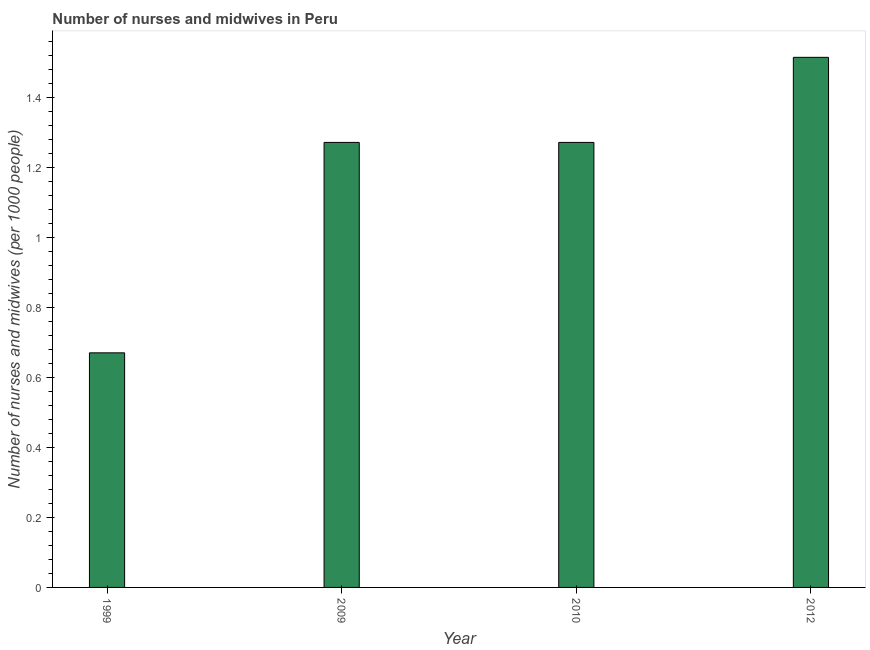Does the graph contain any zero values?
Your answer should be compact. No. What is the title of the graph?
Offer a terse response. Number of nurses and midwives in Peru. What is the label or title of the Y-axis?
Your response must be concise. Number of nurses and midwives (per 1000 people). What is the number of nurses and midwives in 2009?
Offer a terse response. 1.27. Across all years, what is the maximum number of nurses and midwives?
Your answer should be compact. 1.51. Across all years, what is the minimum number of nurses and midwives?
Your response must be concise. 0.67. In which year was the number of nurses and midwives maximum?
Offer a terse response. 2012. What is the sum of the number of nurses and midwives?
Your answer should be very brief. 4.73. What is the difference between the number of nurses and midwives in 1999 and 2009?
Your response must be concise. -0.6. What is the average number of nurses and midwives per year?
Your answer should be compact. 1.18. What is the median number of nurses and midwives?
Provide a succinct answer. 1.27. In how many years, is the number of nurses and midwives greater than 1.52 ?
Provide a short and direct response. 0. Do a majority of the years between 1999 and 2012 (inclusive) have number of nurses and midwives greater than 0.04 ?
Your response must be concise. Yes. What is the ratio of the number of nurses and midwives in 1999 to that in 2009?
Keep it short and to the point. 0.53. Is the difference between the number of nurses and midwives in 2010 and 2012 greater than the difference between any two years?
Offer a terse response. No. What is the difference between the highest and the second highest number of nurses and midwives?
Make the answer very short. 0.24. Is the sum of the number of nurses and midwives in 1999 and 2010 greater than the maximum number of nurses and midwives across all years?
Your answer should be compact. Yes. What is the difference between the highest and the lowest number of nurses and midwives?
Your answer should be very brief. 0.84. In how many years, is the number of nurses and midwives greater than the average number of nurses and midwives taken over all years?
Your answer should be very brief. 3. How many bars are there?
Provide a short and direct response. 4. How many years are there in the graph?
Your response must be concise. 4. Are the values on the major ticks of Y-axis written in scientific E-notation?
Keep it short and to the point. No. What is the Number of nurses and midwives (per 1000 people) of 1999?
Ensure brevity in your answer.  0.67. What is the Number of nurses and midwives (per 1000 people) of 2009?
Offer a terse response. 1.27. What is the Number of nurses and midwives (per 1000 people) in 2010?
Provide a succinct answer. 1.27. What is the Number of nurses and midwives (per 1000 people) of 2012?
Make the answer very short. 1.51. What is the difference between the Number of nurses and midwives (per 1000 people) in 1999 and 2009?
Your answer should be very brief. -0.6. What is the difference between the Number of nurses and midwives (per 1000 people) in 1999 and 2010?
Your answer should be compact. -0.6. What is the difference between the Number of nurses and midwives (per 1000 people) in 1999 and 2012?
Make the answer very short. -0.84. What is the difference between the Number of nurses and midwives (per 1000 people) in 2009 and 2012?
Your answer should be very brief. -0.24. What is the difference between the Number of nurses and midwives (per 1000 people) in 2010 and 2012?
Ensure brevity in your answer.  -0.24. What is the ratio of the Number of nurses and midwives (per 1000 people) in 1999 to that in 2009?
Provide a succinct answer. 0.53. What is the ratio of the Number of nurses and midwives (per 1000 people) in 1999 to that in 2010?
Your response must be concise. 0.53. What is the ratio of the Number of nurses and midwives (per 1000 people) in 1999 to that in 2012?
Offer a very short reply. 0.44. What is the ratio of the Number of nurses and midwives (per 1000 people) in 2009 to that in 2010?
Offer a terse response. 1. What is the ratio of the Number of nurses and midwives (per 1000 people) in 2009 to that in 2012?
Provide a succinct answer. 0.84. What is the ratio of the Number of nurses and midwives (per 1000 people) in 2010 to that in 2012?
Offer a terse response. 0.84. 